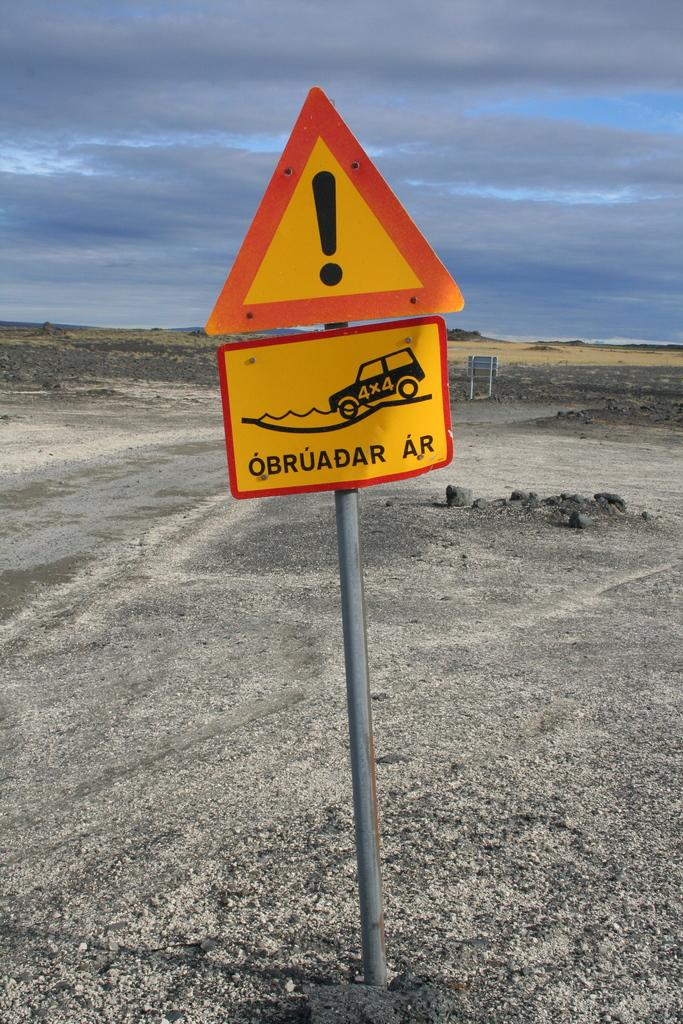What is the main object in the image? There is a pole in the image. What is attached to the pole? There is a sign board on the pole. Where is the pole and sign board located? The pole and sign board are on the ground. How many giants are playing chess on the pole in the image? There are no giants or chess game present in the image. 